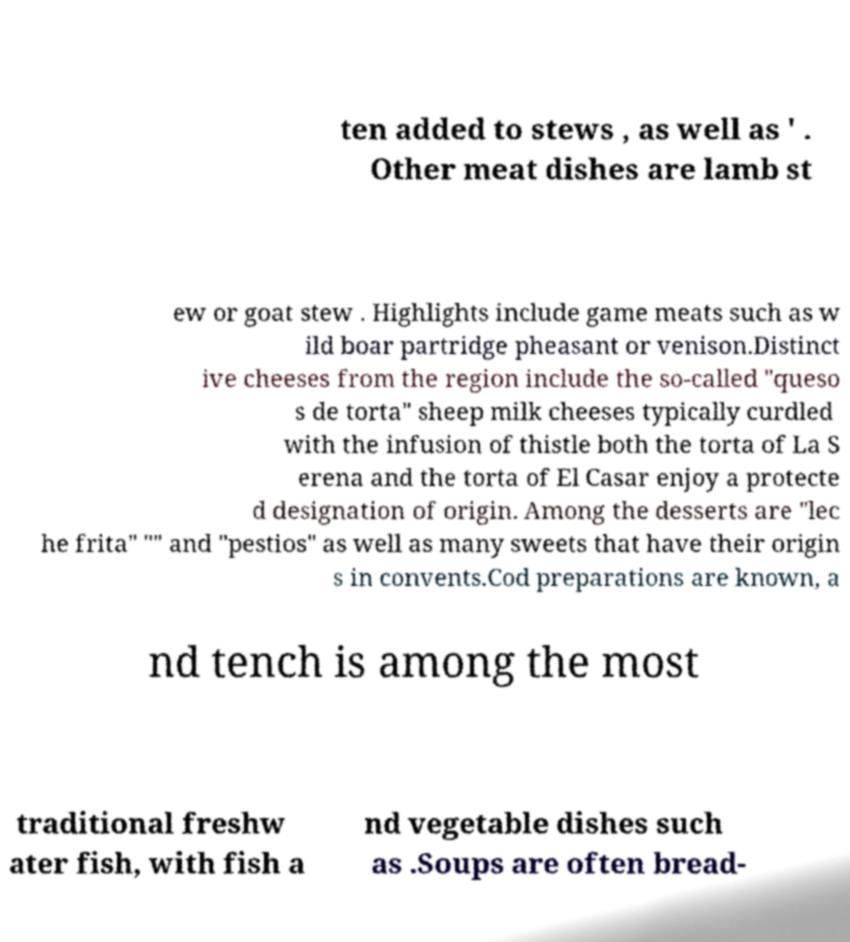What messages or text are displayed in this image? I need them in a readable, typed format. ten added to stews , as well as ' . Other meat dishes are lamb st ew or goat stew . Highlights include game meats such as w ild boar partridge pheasant or venison.Distinct ive cheeses from the region include the so-called "queso s de torta" sheep milk cheeses typically curdled with the infusion of thistle both the torta of La S erena and the torta of El Casar enjoy a protecte d designation of origin. Among the desserts are "lec he frita" "" and "pestios" as well as many sweets that have their origin s in convents.Cod preparations are known, a nd tench is among the most traditional freshw ater fish, with fish a nd vegetable dishes such as .Soups are often bread- 